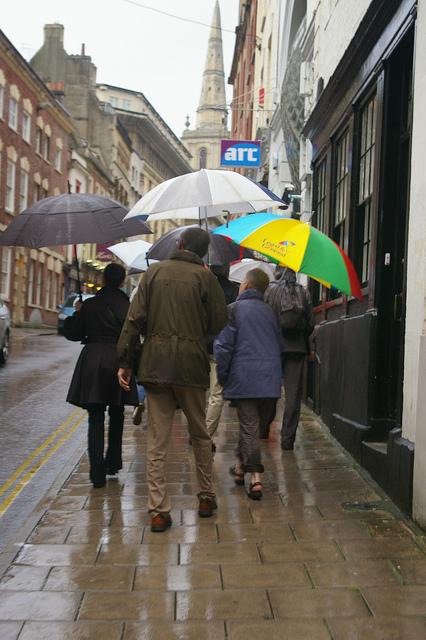Is it raining?
Write a very short answer. Yes. Uphill or Downhill?
Write a very short answer. Uphill. How many umbrellas are seen?
Be succinct. 6. 